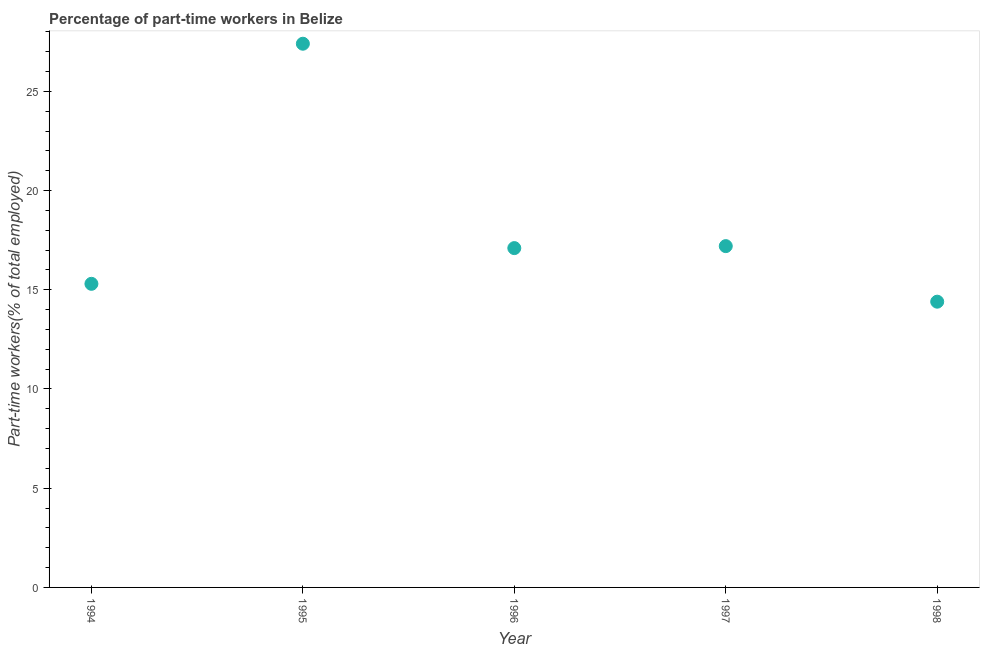What is the percentage of part-time workers in 1997?
Ensure brevity in your answer.  17.2. Across all years, what is the maximum percentage of part-time workers?
Make the answer very short. 27.4. Across all years, what is the minimum percentage of part-time workers?
Provide a succinct answer. 14.4. In which year was the percentage of part-time workers maximum?
Provide a succinct answer. 1995. In which year was the percentage of part-time workers minimum?
Give a very brief answer. 1998. What is the sum of the percentage of part-time workers?
Provide a succinct answer. 91.4. What is the difference between the percentage of part-time workers in 1996 and 1997?
Offer a terse response. -0.1. What is the average percentage of part-time workers per year?
Offer a terse response. 18.28. What is the median percentage of part-time workers?
Offer a very short reply. 17.1. In how many years, is the percentage of part-time workers greater than 20 %?
Offer a terse response. 1. Do a majority of the years between 1998 and 1997 (inclusive) have percentage of part-time workers greater than 23 %?
Provide a short and direct response. No. What is the ratio of the percentage of part-time workers in 1995 to that in 1998?
Your answer should be very brief. 1.9. What is the difference between the highest and the second highest percentage of part-time workers?
Provide a succinct answer. 10.2. Is the sum of the percentage of part-time workers in 1997 and 1998 greater than the maximum percentage of part-time workers across all years?
Offer a very short reply. Yes. What is the difference between the highest and the lowest percentage of part-time workers?
Keep it short and to the point. 13. How many dotlines are there?
Your answer should be compact. 1. What is the difference between two consecutive major ticks on the Y-axis?
Provide a succinct answer. 5. Does the graph contain any zero values?
Ensure brevity in your answer.  No. Does the graph contain grids?
Your answer should be compact. No. What is the title of the graph?
Provide a succinct answer. Percentage of part-time workers in Belize. What is the label or title of the X-axis?
Offer a very short reply. Year. What is the label or title of the Y-axis?
Provide a short and direct response. Part-time workers(% of total employed). What is the Part-time workers(% of total employed) in 1994?
Your answer should be compact. 15.3. What is the Part-time workers(% of total employed) in 1995?
Provide a short and direct response. 27.4. What is the Part-time workers(% of total employed) in 1996?
Give a very brief answer. 17.1. What is the Part-time workers(% of total employed) in 1997?
Provide a succinct answer. 17.2. What is the Part-time workers(% of total employed) in 1998?
Your answer should be compact. 14.4. What is the difference between the Part-time workers(% of total employed) in 1994 and 1996?
Provide a short and direct response. -1.8. What is the difference between the Part-time workers(% of total employed) in 1994 and 1998?
Your response must be concise. 0.9. What is the difference between the Part-time workers(% of total employed) in 1995 and 1997?
Provide a short and direct response. 10.2. What is the difference between the Part-time workers(% of total employed) in 1996 and 1997?
Offer a very short reply. -0.1. What is the difference between the Part-time workers(% of total employed) in 1996 and 1998?
Provide a short and direct response. 2.7. What is the difference between the Part-time workers(% of total employed) in 1997 and 1998?
Provide a short and direct response. 2.8. What is the ratio of the Part-time workers(% of total employed) in 1994 to that in 1995?
Make the answer very short. 0.56. What is the ratio of the Part-time workers(% of total employed) in 1994 to that in 1996?
Provide a short and direct response. 0.9. What is the ratio of the Part-time workers(% of total employed) in 1994 to that in 1997?
Your answer should be very brief. 0.89. What is the ratio of the Part-time workers(% of total employed) in 1994 to that in 1998?
Provide a succinct answer. 1.06. What is the ratio of the Part-time workers(% of total employed) in 1995 to that in 1996?
Keep it short and to the point. 1.6. What is the ratio of the Part-time workers(% of total employed) in 1995 to that in 1997?
Offer a terse response. 1.59. What is the ratio of the Part-time workers(% of total employed) in 1995 to that in 1998?
Give a very brief answer. 1.9. What is the ratio of the Part-time workers(% of total employed) in 1996 to that in 1997?
Offer a terse response. 0.99. What is the ratio of the Part-time workers(% of total employed) in 1996 to that in 1998?
Give a very brief answer. 1.19. What is the ratio of the Part-time workers(% of total employed) in 1997 to that in 1998?
Keep it short and to the point. 1.19. 